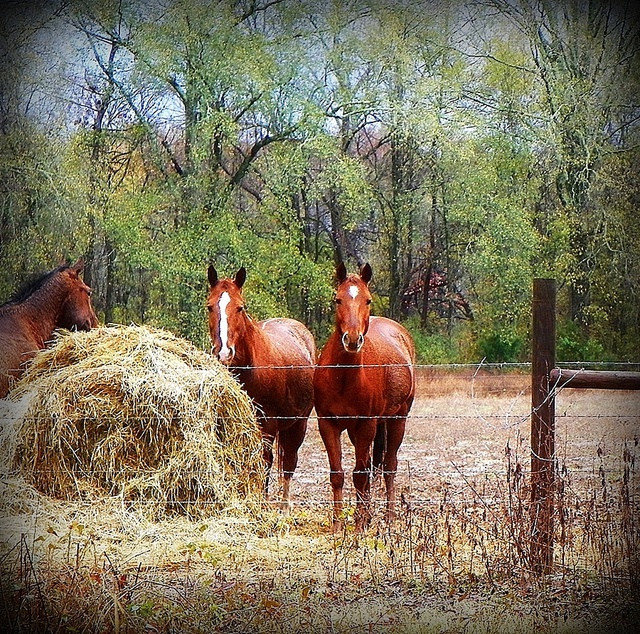Describe the objects in this image and their specific colors. I can see horse in black, maroon, brown, and salmon tones, horse in black, maroon, white, and tan tones, and horse in black, maroon, and brown tones in this image. 